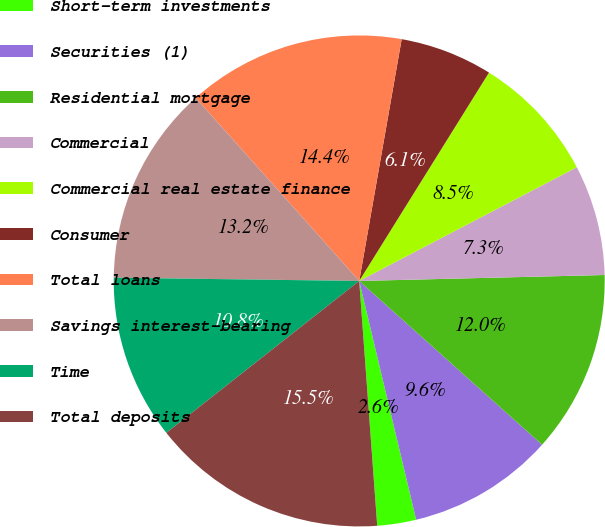<chart> <loc_0><loc_0><loc_500><loc_500><pie_chart><fcel>Short-term investments<fcel>Securities (1)<fcel>Residential mortgage<fcel>Commercial<fcel>Commercial real estate finance<fcel>Consumer<fcel>Total loans<fcel>Savings interest-bearing<fcel>Time<fcel>Total deposits<nl><fcel>2.56%<fcel>9.65%<fcel>12.01%<fcel>7.28%<fcel>8.47%<fcel>6.1%<fcel>14.37%<fcel>13.19%<fcel>10.83%<fcel>15.55%<nl></chart> 